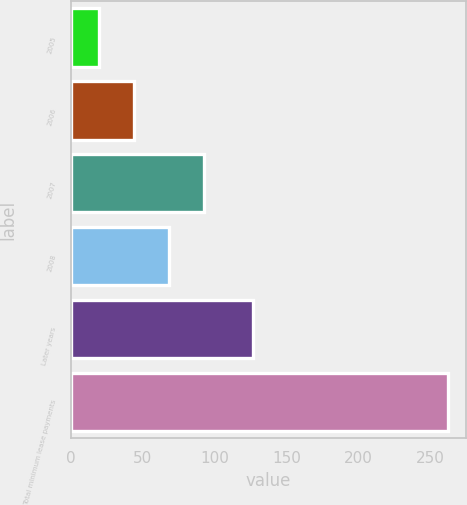Convert chart. <chart><loc_0><loc_0><loc_500><loc_500><bar_chart><fcel>2005<fcel>2006<fcel>2007<fcel>2008<fcel>Later years<fcel>Total minimum lease payments<nl><fcel>20<fcel>44.2<fcel>92.6<fcel>68.4<fcel>127<fcel>262<nl></chart> 